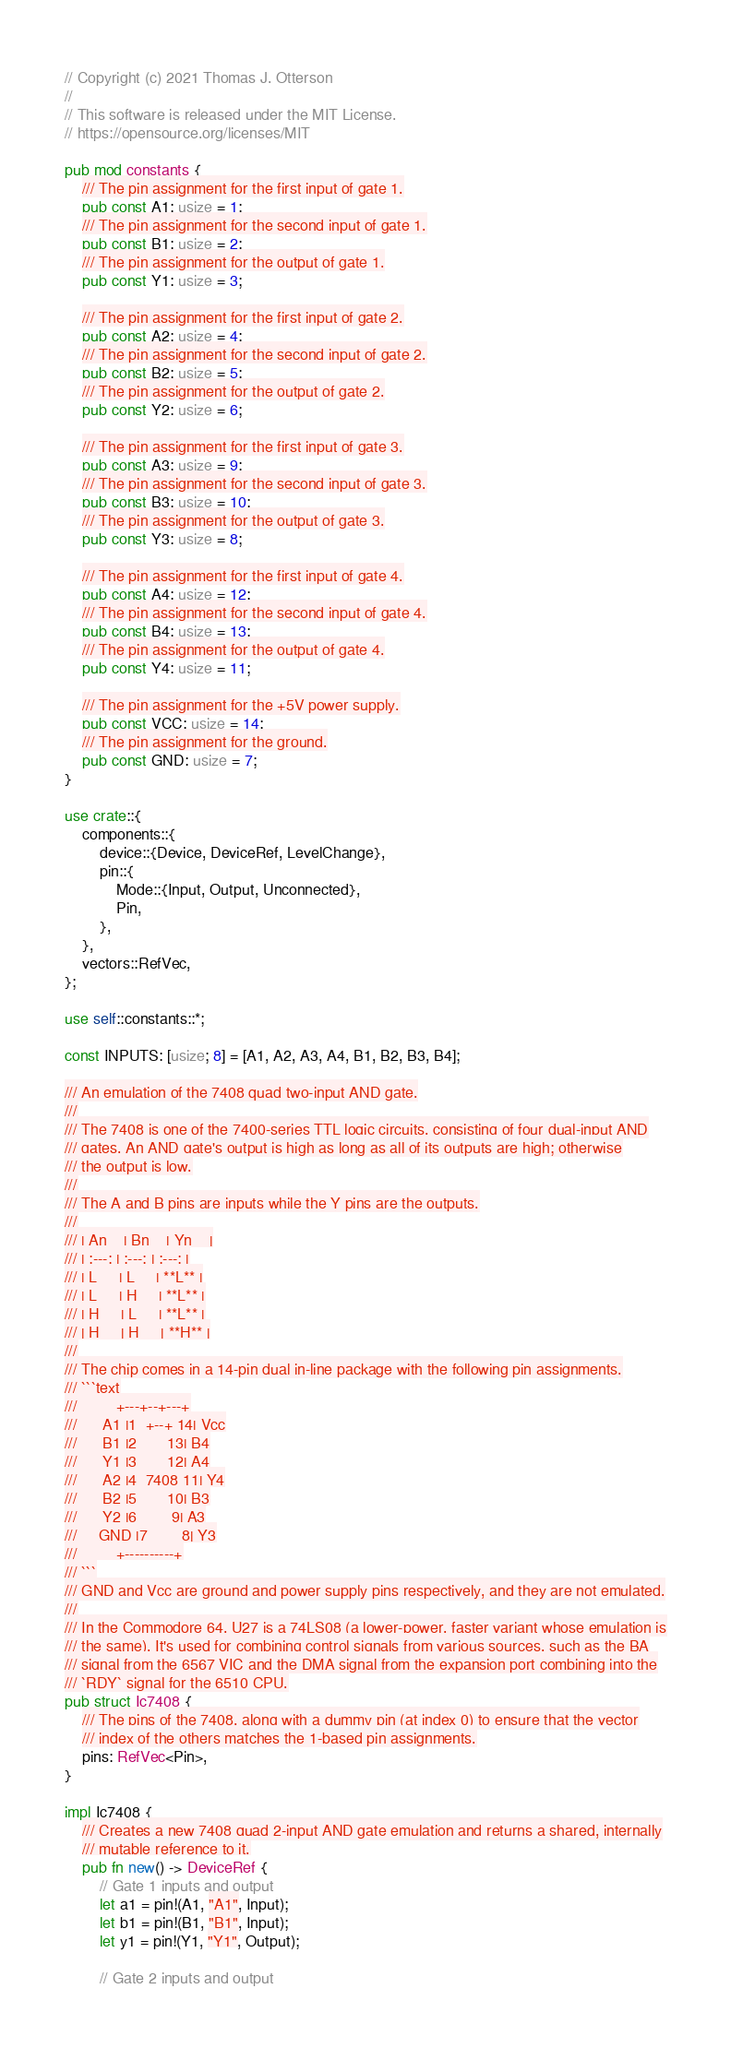Convert code to text. <code><loc_0><loc_0><loc_500><loc_500><_Rust_>// Copyright (c) 2021 Thomas J. Otterson
//
// This software is released under the MIT License.
// https://opensource.org/licenses/MIT

pub mod constants {
    /// The pin assignment for the first input of gate 1.
    pub const A1: usize = 1;
    /// The pin assignment for the second input of gate 1.
    pub const B1: usize = 2;
    /// The pin assignment for the output of gate 1.
    pub const Y1: usize = 3;

    /// The pin assignment for the first input of gate 2.
    pub const A2: usize = 4;
    /// The pin assignment for the second input of gate 2.
    pub const B2: usize = 5;
    /// The pin assignment for the output of gate 2.
    pub const Y2: usize = 6;

    /// The pin assignment for the first input of gate 3.
    pub const A3: usize = 9;
    /// The pin assignment for the second input of gate 3.
    pub const B3: usize = 10;
    /// The pin assignment for the output of gate 3.
    pub const Y3: usize = 8;

    /// The pin assignment for the first input of gate 4.
    pub const A4: usize = 12;
    /// The pin assignment for the second input of gate 4.
    pub const B4: usize = 13;
    /// The pin assignment for the output of gate 4.
    pub const Y4: usize = 11;

    /// The pin assignment for the +5V power supply.
    pub const VCC: usize = 14;
    /// The pin assignment for the ground.
    pub const GND: usize = 7;
}

use crate::{
    components::{
        device::{Device, DeviceRef, LevelChange},
        pin::{
            Mode::{Input, Output, Unconnected},
            Pin,
        },
    },
    vectors::RefVec,
};

use self::constants::*;

const INPUTS: [usize; 8] = [A1, A2, A3, A4, B1, B2, B3, B4];

/// An emulation of the 7408 quad two-input AND gate.
///
/// The 7408 is one of the 7400-series TTL logic circuits, consisting of four dual-input AND
/// gates. An AND gate's output is high as long as all of its outputs are high; otherwise
/// the output is low.
///
/// The A and B pins are inputs while the Y pins are the outputs.
///
/// | An    | Bn    | Yn    |
/// | :---: | :---: | :---: |
/// | L     | L     | **L** |
/// | L     | H     | **L** |
/// | H     | L     | **L** |
/// | H     | H     | **H** |
///
/// The chip comes in a 14-pin dual in-line package with the following pin assignments.
/// ```text
///         +---+--+---+
///      A1 |1  +--+ 14| Vcc
///      B1 |2       13| B4
///      Y1 |3       12| A4
///      A2 |4  7408 11| Y4
///      B2 |5       10| B3
///      Y2 |6        9| A3
///     GND |7        8| Y3
///         +----------+
/// ```
/// GND and Vcc are ground and power supply pins respectively, and they are not emulated.
///
/// In the Commodore 64, U27 is a 74LS08 (a lower-power, faster variant whose emulation is
/// the same). It's used for combining control signals from various sources, such as the BA
/// signal from the 6567 VIC and the DMA signal from the expansion port combining into the
/// `RDY` signal for the 6510 CPU.
pub struct Ic7408 {
    /// The pins of the 7408, along with a dummy pin (at index 0) to ensure that the vector
    /// index of the others matches the 1-based pin assignments.
    pins: RefVec<Pin>,
}

impl Ic7408 {
    /// Creates a new 7408 quad 2-input AND gate emulation and returns a shared, internally
    /// mutable reference to it.
    pub fn new() -> DeviceRef {
        // Gate 1 inputs and output
        let a1 = pin!(A1, "A1", Input);
        let b1 = pin!(B1, "B1", Input);
        let y1 = pin!(Y1, "Y1", Output);

        // Gate 2 inputs and output</code> 